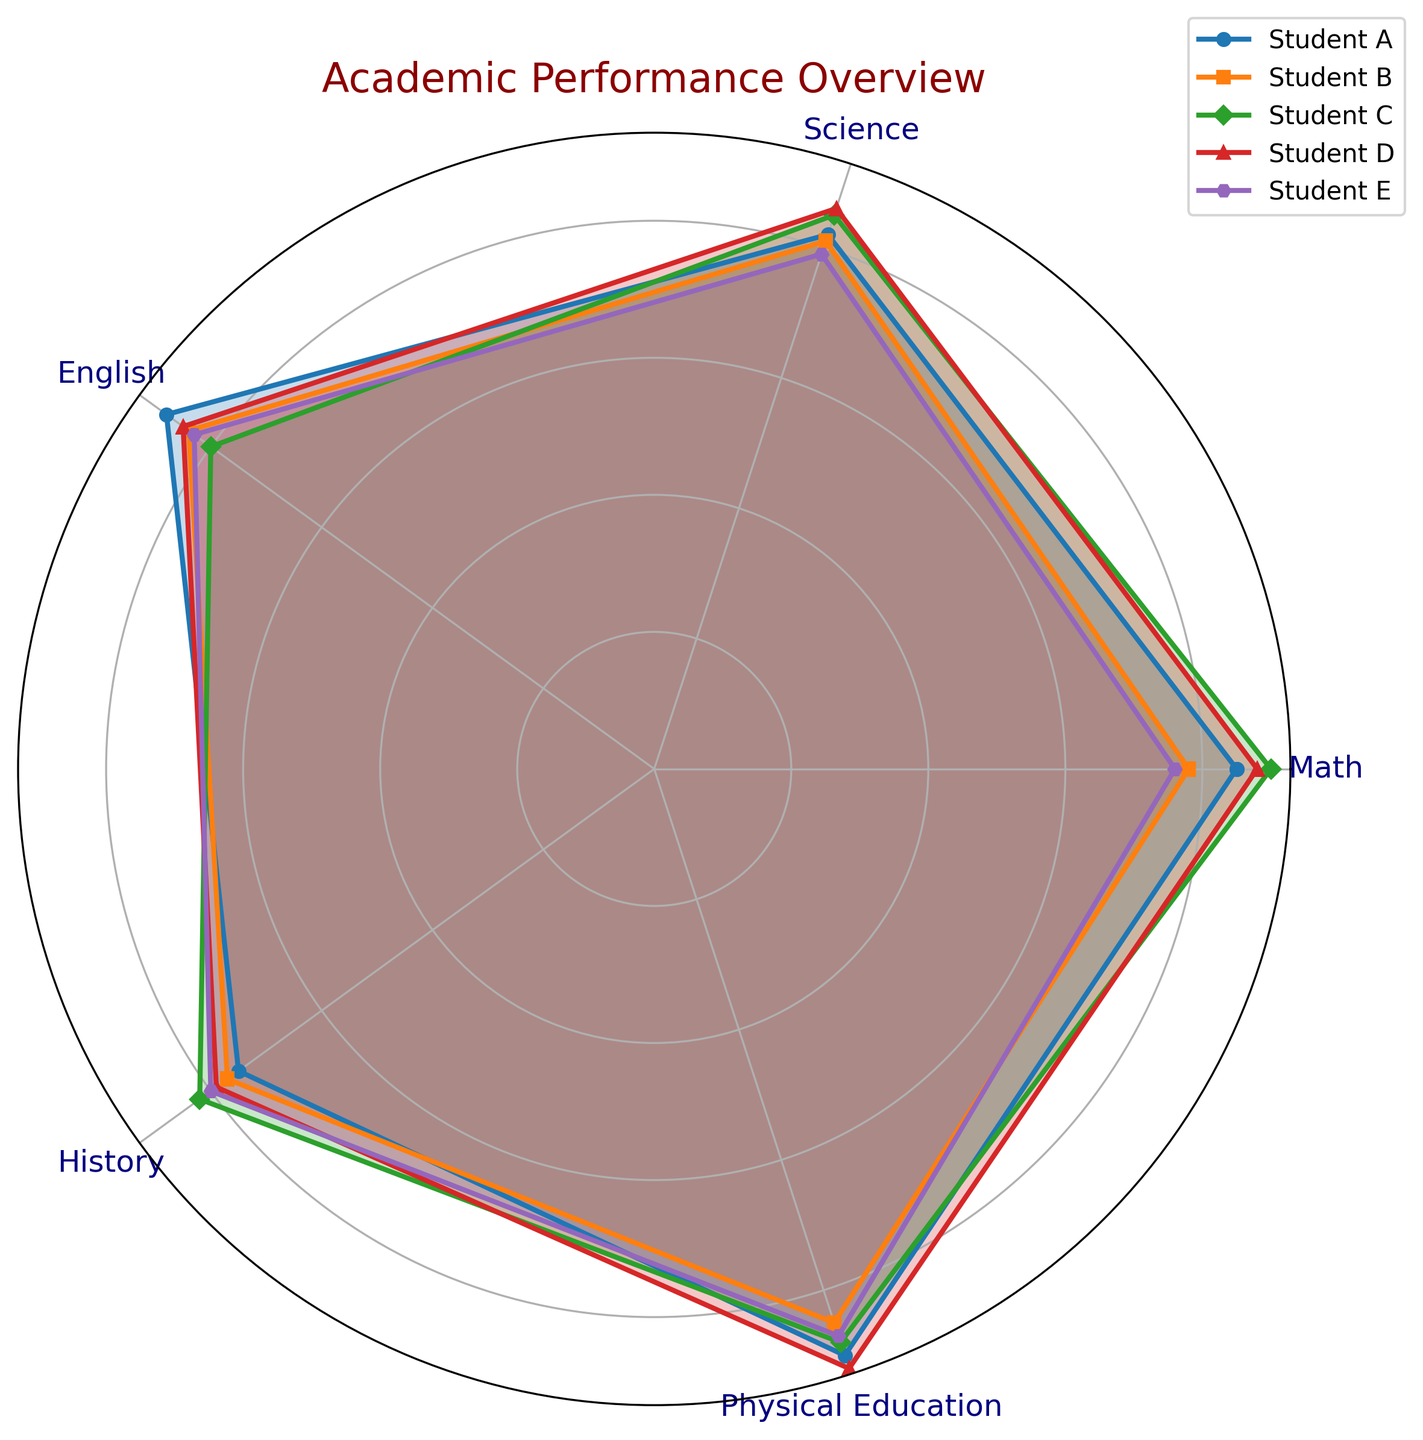Which student scored the highest in Physical Education? Look at the segment for Physical Education (PE) and compare the outermost points. The student with the highest point is Student D with a score of 92.
Answer: Student D Which subject has the lowest overall average score? Calculate the average score for each subject: Math (83.4), Science (82.6), English (84), History (78.6), Physical Education (88.4). The lowest average score is in History.
Answer: History Which two students have the most similar overall performance profile? Compare the shapes and sizes of the polygons for each student. Student B and Student E have the most similar performance profiles when comparing their values across all subjects.
Answer: Student B and Student E What is the combined score of Student A in Math and Science? Add Student A's scores in Math (85) and Science (82) which results in 85 + 82 = 167.
Answer: 167 How does Student C's performance in Math compare to Student E's? Check the Math score for both students: Student C scores 90, and Student E scores 76. Student C scored higher than Student E in Math.
Answer: Student C scored higher Which student has the most balanced performance across all subjects? Look for the student whose polygon is closest to a regular shape (circle-like). Student D’s performance appears the most balanced, with scores close together across all subjects.
Answer: Student D What's the difference in History scores between the highest and lowest scoring students? Identify the highest (82 by Student C) and lowest (75 by Student A) scores in History. The difference is 82 - 75 = 7.
Answer: 7 Who performed better in Science, Student B or Student D? Look at the Science scores: Student B scored 81, while Student D scored 86. Student D performed better in Science.
Answer: Student D What's Student E's weakest subject? Find the lowest score for Student E across all subjects: Math (76), Science (79), English (83), History (80), and Physical Education (87). The lowest score is in Math.
Answer: Math 